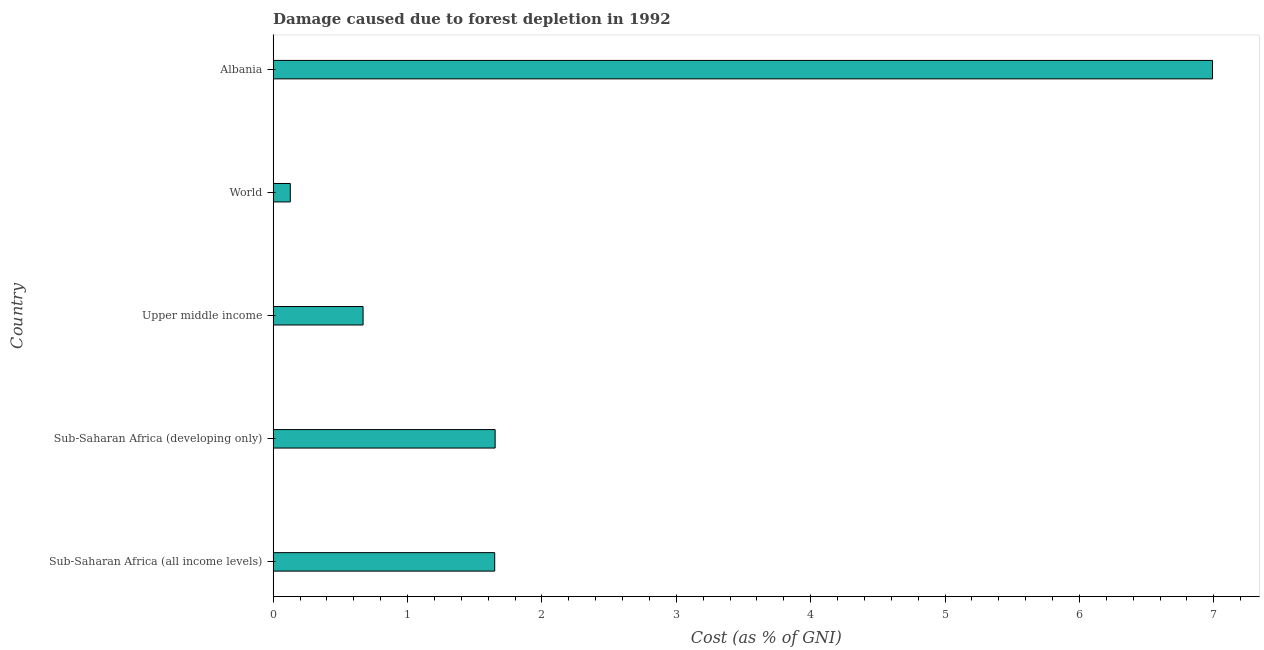Does the graph contain any zero values?
Ensure brevity in your answer.  No. Does the graph contain grids?
Offer a terse response. No. What is the title of the graph?
Ensure brevity in your answer.  Damage caused due to forest depletion in 1992. What is the label or title of the X-axis?
Make the answer very short. Cost (as % of GNI). What is the damage caused due to forest depletion in Albania?
Offer a very short reply. 6.99. Across all countries, what is the maximum damage caused due to forest depletion?
Your answer should be compact. 6.99. Across all countries, what is the minimum damage caused due to forest depletion?
Keep it short and to the point. 0.13. In which country was the damage caused due to forest depletion maximum?
Your answer should be compact. Albania. What is the sum of the damage caused due to forest depletion?
Provide a short and direct response. 11.09. What is the difference between the damage caused due to forest depletion in Upper middle income and World?
Offer a very short reply. 0.54. What is the average damage caused due to forest depletion per country?
Your answer should be compact. 2.22. What is the median damage caused due to forest depletion?
Offer a very short reply. 1.65. In how many countries, is the damage caused due to forest depletion greater than 1.6 %?
Provide a short and direct response. 3. What is the ratio of the damage caused due to forest depletion in Sub-Saharan Africa (all income levels) to that in World?
Offer a terse response. 12.91. What is the difference between the highest and the second highest damage caused due to forest depletion?
Provide a short and direct response. 5.34. Is the sum of the damage caused due to forest depletion in Sub-Saharan Africa (all income levels) and Upper middle income greater than the maximum damage caused due to forest depletion across all countries?
Provide a short and direct response. No. What is the difference between the highest and the lowest damage caused due to forest depletion?
Make the answer very short. 6.86. In how many countries, is the damage caused due to forest depletion greater than the average damage caused due to forest depletion taken over all countries?
Ensure brevity in your answer.  1. How many bars are there?
Ensure brevity in your answer.  5. Are all the bars in the graph horizontal?
Ensure brevity in your answer.  Yes. Are the values on the major ticks of X-axis written in scientific E-notation?
Make the answer very short. No. What is the Cost (as % of GNI) of Sub-Saharan Africa (all income levels)?
Your answer should be compact. 1.65. What is the Cost (as % of GNI) in Sub-Saharan Africa (developing only)?
Make the answer very short. 1.65. What is the Cost (as % of GNI) in Upper middle income?
Ensure brevity in your answer.  0.67. What is the Cost (as % of GNI) in World?
Offer a very short reply. 0.13. What is the Cost (as % of GNI) of Albania?
Offer a terse response. 6.99. What is the difference between the Cost (as % of GNI) in Sub-Saharan Africa (all income levels) and Sub-Saharan Africa (developing only)?
Keep it short and to the point. -0. What is the difference between the Cost (as % of GNI) in Sub-Saharan Africa (all income levels) and Upper middle income?
Provide a short and direct response. 0.98. What is the difference between the Cost (as % of GNI) in Sub-Saharan Africa (all income levels) and World?
Your response must be concise. 1.52. What is the difference between the Cost (as % of GNI) in Sub-Saharan Africa (all income levels) and Albania?
Keep it short and to the point. -5.34. What is the difference between the Cost (as % of GNI) in Sub-Saharan Africa (developing only) and Upper middle income?
Your answer should be very brief. 0.98. What is the difference between the Cost (as % of GNI) in Sub-Saharan Africa (developing only) and World?
Ensure brevity in your answer.  1.52. What is the difference between the Cost (as % of GNI) in Sub-Saharan Africa (developing only) and Albania?
Provide a short and direct response. -5.34. What is the difference between the Cost (as % of GNI) in Upper middle income and World?
Offer a terse response. 0.54. What is the difference between the Cost (as % of GNI) in Upper middle income and Albania?
Your answer should be compact. -6.32. What is the difference between the Cost (as % of GNI) in World and Albania?
Offer a very short reply. -6.86. What is the ratio of the Cost (as % of GNI) in Sub-Saharan Africa (all income levels) to that in Sub-Saharan Africa (developing only)?
Provide a short and direct response. 1. What is the ratio of the Cost (as % of GNI) in Sub-Saharan Africa (all income levels) to that in Upper middle income?
Make the answer very short. 2.46. What is the ratio of the Cost (as % of GNI) in Sub-Saharan Africa (all income levels) to that in World?
Ensure brevity in your answer.  12.91. What is the ratio of the Cost (as % of GNI) in Sub-Saharan Africa (all income levels) to that in Albania?
Offer a very short reply. 0.24. What is the ratio of the Cost (as % of GNI) in Sub-Saharan Africa (developing only) to that in Upper middle income?
Provide a succinct answer. 2.47. What is the ratio of the Cost (as % of GNI) in Sub-Saharan Africa (developing only) to that in World?
Provide a succinct answer. 12.93. What is the ratio of the Cost (as % of GNI) in Sub-Saharan Africa (developing only) to that in Albania?
Your answer should be very brief. 0.24. What is the ratio of the Cost (as % of GNI) in Upper middle income to that in World?
Provide a short and direct response. 5.24. What is the ratio of the Cost (as % of GNI) in Upper middle income to that in Albania?
Offer a terse response. 0.1. What is the ratio of the Cost (as % of GNI) in World to that in Albania?
Provide a succinct answer. 0.02. 